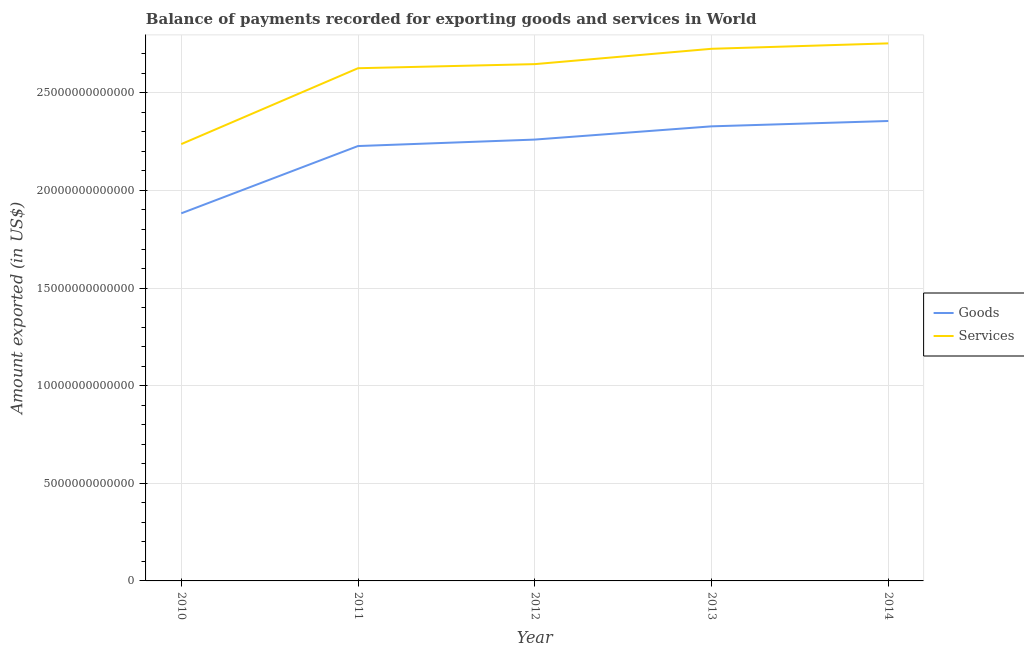How many different coloured lines are there?
Your answer should be very brief. 2. Does the line corresponding to amount of services exported intersect with the line corresponding to amount of goods exported?
Provide a short and direct response. No. What is the amount of services exported in 2012?
Provide a succinct answer. 2.65e+13. Across all years, what is the maximum amount of goods exported?
Ensure brevity in your answer.  2.36e+13. Across all years, what is the minimum amount of goods exported?
Provide a short and direct response. 1.88e+13. In which year was the amount of goods exported minimum?
Provide a succinct answer. 2010. What is the total amount of services exported in the graph?
Your response must be concise. 1.30e+14. What is the difference between the amount of services exported in 2010 and that in 2013?
Keep it short and to the point. -4.88e+12. What is the difference between the amount of services exported in 2012 and the amount of goods exported in 2010?
Provide a short and direct response. 7.64e+12. What is the average amount of goods exported per year?
Ensure brevity in your answer.  2.21e+13. In the year 2012, what is the difference between the amount of services exported and amount of goods exported?
Keep it short and to the point. 3.86e+12. What is the ratio of the amount of services exported in 2010 to that in 2012?
Provide a short and direct response. 0.85. Is the amount of services exported in 2010 less than that in 2012?
Provide a succinct answer. Yes. What is the difference between the highest and the second highest amount of services exported?
Provide a succinct answer. 2.78e+11. What is the difference between the highest and the lowest amount of services exported?
Provide a succinct answer. 5.16e+12. In how many years, is the amount of goods exported greater than the average amount of goods exported taken over all years?
Provide a short and direct response. 4. Does the amount of goods exported monotonically increase over the years?
Offer a very short reply. Yes. How many lines are there?
Ensure brevity in your answer.  2. How many years are there in the graph?
Give a very brief answer. 5. What is the difference between two consecutive major ticks on the Y-axis?
Ensure brevity in your answer.  5.00e+12. Are the values on the major ticks of Y-axis written in scientific E-notation?
Ensure brevity in your answer.  No. Does the graph contain grids?
Make the answer very short. Yes. Where does the legend appear in the graph?
Your response must be concise. Center right. How many legend labels are there?
Your response must be concise. 2. What is the title of the graph?
Give a very brief answer. Balance of payments recorded for exporting goods and services in World. What is the label or title of the X-axis?
Your response must be concise. Year. What is the label or title of the Y-axis?
Keep it short and to the point. Amount exported (in US$). What is the Amount exported (in US$) in Goods in 2010?
Your answer should be very brief. 1.88e+13. What is the Amount exported (in US$) of Services in 2010?
Provide a succinct answer. 2.24e+13. What is the Amount exported (in US$) in Goods in 2011?
Offer a very short reply. 2.23e+13. What is the Amount exported (in US$) of Services in 2011?
Keep it short and to the point. 2.63e+13. What is the Amount exported (in US$) in Goods in 2012?
Your response must be concise. 2.26e+13. What is the Amount exported (in US$) in Services in 2012?
Ensure brevity in your answer.  2.65e+13. What is the Amount exported (in US$) in Goods in 2013?
Your answer should be compact. 2.33e+13. What is the Amount exported (in US$) of Services in 2013?
Your answer should be compact. 2.73e+13. What is the Amount exported (in US$) of Goods in 2014?
Offer a terse response. 2.36e+13. What is the Amount exported (in US$) in Services in 2014?
Your answer should be compact. 2.75e+13. Across all years, what is the maximum Amount exported (in US$) in Goods?
Ensure brevity in your answer.  2.36e+13. Across all years, what is the maximum Amount exported (in US$) of Services?
Your answer should be compact. 2.75e+13. Across all years, what is the minimum Amount exported (in US$) of Goods?
Your answer should be very brief. 1.88e+13. Across all years, what is the minimum Amount exported (in US$) of Services?
Make the answer very short. 2.24e+13. What is the total Amount exported (in US$) of Goods in the graph?
Offer a very short reply. 1.11e+14. What is the total Amount exported (in US$) in Services in the graph?
Offer a terse response. 1.30e+14. What is the difference between the Amount exported (in US$) of Goods in 2010 and that in 2011?
Offer a terse response. -3.45e+12. What is the difference between the Amount exported (in US$) in Services in 2010 and that in 2011?
Give a very brief answer. -3.89e+12. What is the difference between the Amount exported (in US$) of Goods in 2010 and that in 2012?
Your response must be concise. -3.78e+12. What is the difference between the Amount exported (in US$) of Services in 2010 and that in 2012?
Provide a short and direct response. -4.10e+12. What is the difference between the Amount exported (in US$) in Goods in 2010 and that in 2013?
Your response must be concise. -4.46e+12. What is the difference between the Amount exported (in US$) in Services in 2010 and that in 2013?
Offer a terse response. -4.88e+12. What is the difference between the Amount exported (in US$) in Goods in 2010 and that in 2014?
Your response must be concise. -4.73e+12. What is the difference between the Amount exported (in US$) of Services in 2010 and that in 2014?
Ensure brevity in your answer.  -5.16e+12. What is the difference between the Amount exported (in US$) in Goods in 2011 and that in 2012?
Make the answer very short. -3.31e+11. What is the difference between the Amount exported (in US$) in Services in 2011 and that in 2012?
Provide a succinct answer. -2.10e+11. What is the difference between the Amount exported (in US$) of Goods in 2011 and that in 2013?
Give a very brief answer. -1.01e+12. What is the difference between the Amount exported (in US$) of Services in 2011 and that in 2013?
Your answer should be compact. -9.95e+11. What is the difference between the Amount exported (in US$) in Goods in 2011 and that in 2014?
Your answer should be compact. -1.28e+12. What is the difference between the Amount exported (in US$) in Services in 2011 and that in 2014?
Make the answer very short. -1.27e+12. What is the difference between the Amount exported (in US$) in Goods in 2012 and that in 2013?
Give a very brief answer. -6.77e+11. What is the difference between the Amount exported (in US$) of Services in 2012 and that in 2013?
Your answer should be very brief. -7.85e+11. What is the difference between the Amount exported (in US$) of Goods in 2012 and that in 2014?
Your response must be concise. -9.52e+11. What is the difference between the Amount exported (in US$) in Services in 2012 and that in 2014?
Offer a terse response. -1.06e+12. What is the difference between the Amount exported (in US$) in Goods in 2013 and that in 2014?
Provide a short and direct response. -2.74e+11. What is the difference between the Amount exported (in US$) of Services in 2013 and that in 2014?
Make the answer very short. -2.78e+11. What is the difference between the Amount exported (in US$) of Goods in 2010 and the Amount exported (in US$) of Services in 2011?
Provide a succinct answer. -7.43e+12. What is the difference between the Amount exported (in US$) of Goods in 2010 and the Amount exported (in US$) of Services in 2012?
Offer a terse response. -7.64e+12. What is the difference between the Amount exported (in US$) of Goods in 2010 and the Amount exported (in US$) of Services in 2013?
Keep it short and to the point. -8.43e+12. What is the difference between the Amount exported (in US$) of Goods in 2010 and the Amount exported (in US$) of Services in 2014?
Your answer should be compact. -8.71e+12. What is the difference between the Amount exported (in US$) of Goods in 2011 and the Amount exported (in US$) of Services in 2012?
Make the answer very short. -4.20e+12. What is the difference between the Amount exported (in US$) in Goods in 2011 and the Amount exported (in US$) in Services in 2013?
Ensure brevity in your answer.  -4.98e+12. What is the difference between the Amount exported (in US$) of Goods in 2011 and the Amount exported (in US$) of Services in 2014?
Provide a short and direct response. -5.26e+12. What is the difference between the Amount exported (in US$) of Goods in 2012 and the Amount exported (in US$) of Services in 2013?
Provide a succinct answer. -4.65e+12. What is the difference between the Amount exported (in US$) in Goods in 2012 and the Amount exported (in US$) in Services in 2014?
Provide a short and direct response. -4.93e+12. What is the difference between the Amount exported (in US$) of Goods in 2013 and the Amount exported (in US$) of Services in 2014?
Your response must be concise. -4.25e+12. What is the average Amount exported (in US$) of Goods per year?
Offer a terse response. 2.21e+13. What is the average Amount exported (in US$) of Services per year?
Make the answer very short. 2.60e+13. In the year 2010, what is the difference between the Amount exported (in US$) in Goods and Amount exported (in US$) in Services?
Make the answer very short. -3.55e+12. In the year 2011, what is the difference between the Amount exported (in US$) in Goods and Amount exported (in US$) in Services?
Your response must be concise. -3.99e+12. In the year 2012, what is the difference between the Amount exported (in US$) of Goods and Amount exported (in US$) of Services?
Your answer should be compact. -3.86e+12. In the year 2013, what is the difference between the Amount exported (in US$) in Goods and Amount exported (in US$) in Services?
Offer a very short reply. -3.97e+12. In the year 2014, what is the difference between the Amount exported (in US$) of Goods and Amount exported (in US$) of Services?
Make the answer very short. -3.98e+12. What is the ratio of the Amount exported (in US$) in Goods in 2010 to that in 2011?
Provide a succinct answer. 0.85. What is the ratio of the Amount exported (in US$) of Services in 2010 to that in 2011?
Keep it short and to the point. 0.85. What is the ratio of the Amount exported (in US$) in Goods in 2010 to that in 2012?
Your answer should be very brief. 0.83. What is the ratio of the Amount exported (in US$) in Services in 2010 to that in 2012?
Your answer should be very brief. 0.85. What is the ratio of the Amount exported (in US$) of Goods in 2010 to that in 2013?
Your answer should be very brief. 0.81. What is the ratio of the Amount exported (in US$) in Services in 2010 to that in 2013?
Your answer should be compact. 0.82. What is the ratio of the Amount exported (in US$) in Goods in 2010 to that in 2014?
Offer a terse response. 0.8. What is the ratio of the Amount exported (in US$) of Services in 2010 to that in 2014?
Your answer should be very brief. 0.81. What is the ratio of the Amount exported (in US$) of Goods in 2011 to that in 2013?
Provide a short and direct response. 0.96. What is the ratio of the Amount exported (in US$) of Services in 2011 to that in 2013?
Make the answer very short. 0.96. What is the ratio of the Amount exported (in US$) of Goods in 2011 to that in 2014?
Make the answer very short. 0.95. What is the ratio of the Amount exported (in US$) of Services in 2011 to that in 2014?
Keep it short and to the point. 0.95. What is the ratio of the Amount exported (in US$) in Goods in 2012 to that in 2013?
Provide a short and direct response. 0.97. What is the ratio of the Amount exported (in US$) in Services in 2012 to that in 2013?
Provide a short and direct response. 0.97. What is the ratio of the Amount exported (in US$) of Goods in 2012 to that in 2014?
Your answer should be compact. 0.96. What is the ratio of the Amount exported (in US$) of Services in 2012 to that in 2014?
Your answer should be very brief. 0.96. What is the ratio of the Amount exported (in US$) of Goods in 2013 to that in 2014?
Provide a short and direct response. 0.99. What is the ratio of the Amount exported (in US$) of Services in 2013 to that in 2014?
Make the answer very short. 0.99. What is the difference between the highest and the second highest Amount exported (in US$) of Goods?
Your answer should be very brief. 2.74e+11. What is the difference between the highest and the second highest Amount exported (in US$) in Services?
Ensure brevity in your answer.  2.78e+11. What is the difference between the highest and the lowest Amount exported (in US$) of Goods?
Your answer should be compact. 4.73e+12. What is the difference between the highest and the lowest Amount exported (in US$) in Services?
Keep it short and to the point. 5.16e+12. 